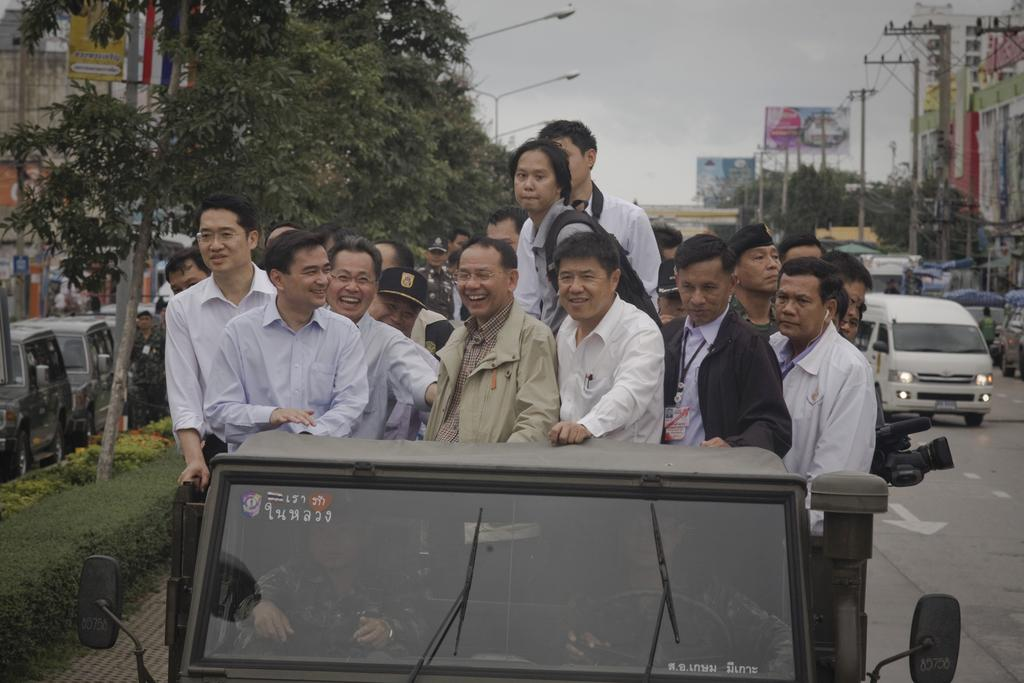What are the people in the image doing? The people in the image are standing on vehicles. What can be seen in the background of the image? There are trees, buildings, street lamps, current poles, banners, and plants visible in the background. What else is present in the image besides the people and background? Vehicles are visible in the image. What type of lock can be seen securing the pie in the image? There is no pie or lock present in the image. How does the water affect the people and vehicles in the image? There is no water present in the image; it is a dry scene with people, vehicles, and background elements. 